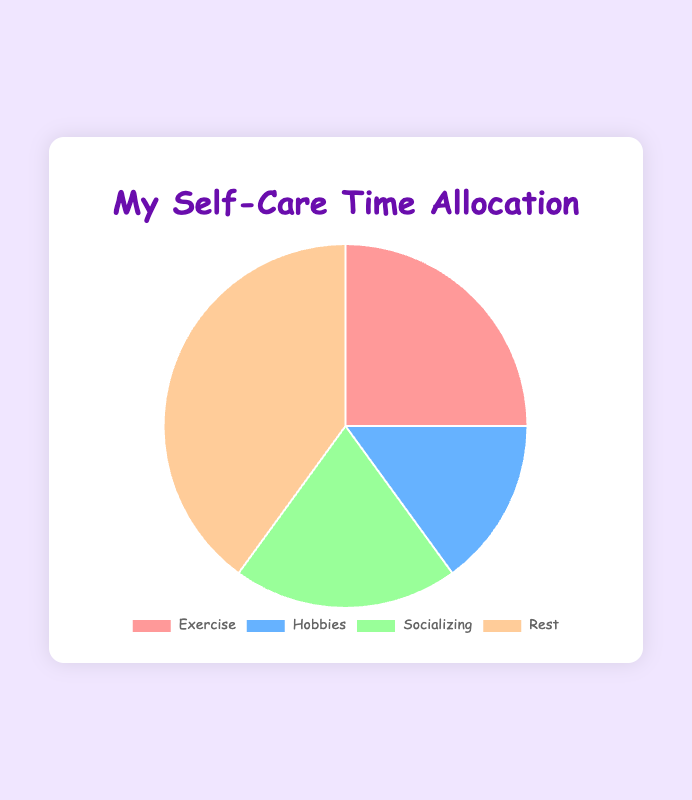What activity takes up the largest portion of my self-care time? The activity with the highest percentage in the pie chart is the one that takes up the largest portion of self-care time. Here, "Rest" has the highest percentage at 40%.
Answer: Rest Which activity has the smallest share of my self-care time? The smallest share of self-care time will be the activity with the lowest percentage. In the chart, "Hobbies" has the smallest share at 15%.
Answer: Hobbies What is the combined percentage of time spent on Exercise and Socializing? To find the combined percentage, add the percentages of Exercise and Socializing. Exercise is 25% and Socializing is 20%, so the combined percentage is 25% + 20% = 45%.
Answer: 45% How much more time do I spend on Rest compared to Socializing? Subtract the percentage of Socializing from the percentage of Rest. Rest is 40% and Socializing is 20%, so the difference is 40% - 20% = 20%.
Answer: 20% Which activity has a percentage between Hobbies and Rest in terms of self-care time? In the order of percentages: Hobbies (15%), Socializing (20%), and Rest (40%), the activity between Hobbies and Rest is Socializing with 20%.
Answer: Socializing If I decided to allocate 5% more of my time from Rest to Hobbies, what would the new percentages be for these activities? Subtract 5% from Rest and add it to Hobbies. Originally, Rest is 40% and Hobbies are 15%. The new percentages would be Rest: 40% - 5% = 35%, Hobbies: 15% + 5% = 20%.
Answer: Rest: 35%, Hobbies: 20% Which two activities together make up half of my self-care time? Find two activities whose combined percentages equal 50%. Here, Rest is 40% and Socializing is 20%, so adding these together: 40% + 20% = 60%, and since the combined percentage of Exercise (25%) and Hobbies (15%) is also less than half: 25% + 15% = 40%, no exact match found. The closest match would be two activities that sum greater than or close to 50% such as (Rest 40% and any other activity more than 10%). So the correct exact non-answer would be
Answer: No exact match What is the average percentage of time spent on all activities? To find the average percentage, sum up all the percentages and divide by the number of activities. (25% + 15% + 20% + 40%) / 4 = 100% / 4 = 25%.
Answer: 25% 